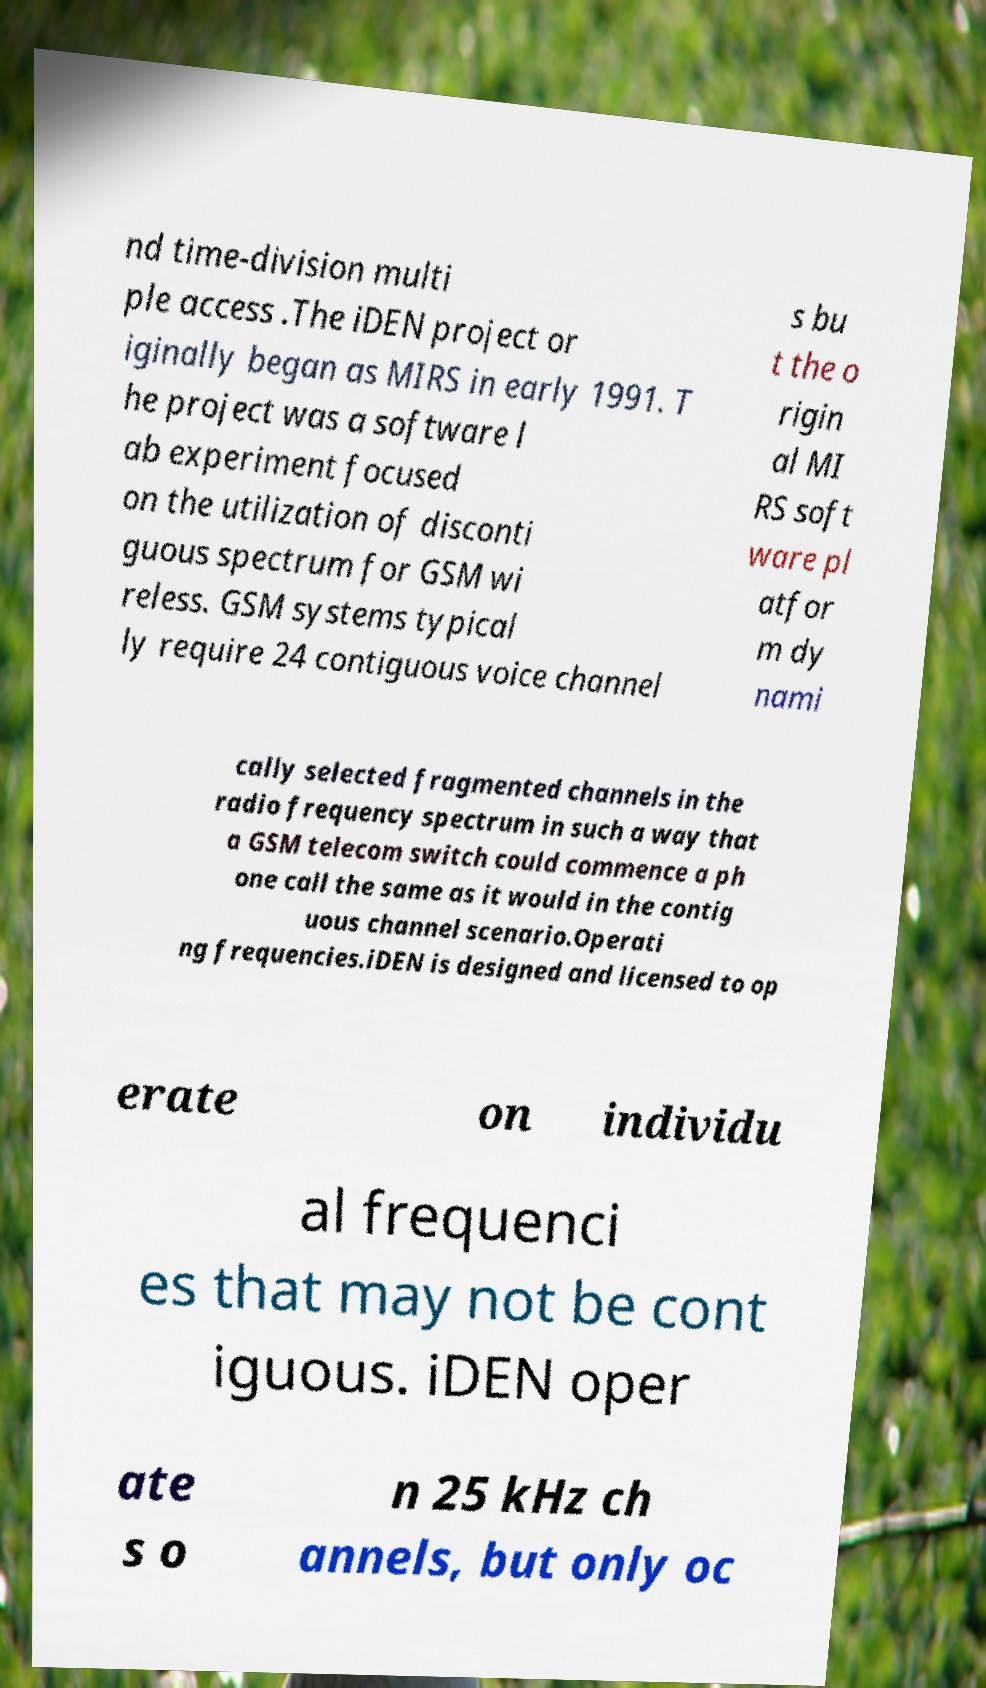Can you read and provide the text displayed in the image?This photo seems to have some interesting text. Can you extract and type it out for me? nd time-division multi ple access .The iDEN project or iginally began as MIRS in early 1991. T he project was a software l ab experiment focused on the utilization of disconti guous spectrum for GSM wi reless. GSM systems typical ly require 24 contiguous voice channel s bu t the o rigin al MI RS soft ware pl atfor m dy nami cally selected fragmented channels in the radio frequency spectrum in such a way that a GSM telecom switch could commence a ph one call the same as it would in the contig uous channel scenario.Operati ng frequencies.iDEN is designed and licensed to op erate on individu al frequenci es that may not be cont iguous. iDEN oper ate s o n 25 kHz ch annels, but only oc 